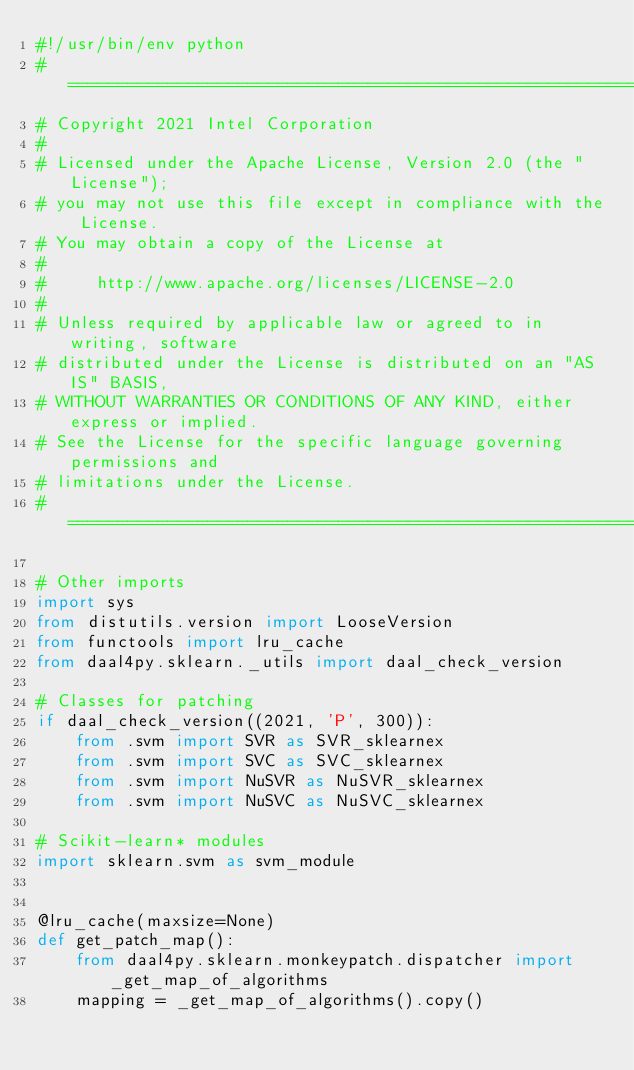<code> <loc_0><loc_0><loc_500><loc_500><_Python_>#!/usr/bin/env python
#===============================================================================
# Copyright 2021 Intel Corporation
#
# Licensed under the Apache License, Version 2.0 (the "License");
# you may not use this file except in compliance with the License.
# You may obtain a copy of the License at
#
#     http://www.apache.org/licenses/LICENSE-2.0
#
# Unless required by applicable law or agreed to in writing, software
# distributed under the License is distributed on an "AS IS" BASIS,
# WITHOUT WARRANTIES OR CONDITIONS OF ANY KIND, either express or implied.
# See the License for the specific language governing permissions and
# limitations under the License.
#===============================================================================

# Other imports
import sys
from distutils.version import LooseVersion
from functools import lru_cache
from daal4py.sklearn._utils import daal_check_version

# Classes for patching
if daal_check_version((2021, 'P', 300)):
    from .svm import SVR as SVR_sklearnex
    from .svm import SVC as SVC_sklearnex
    from .svm import NuSVR as NuSVR_sklearnex
    from .svm import NuSVC as NuSVC_sklearnex

# Scikit-learn* modules
import sklearn.svm as svm_module


@lru_cache(maxsize=None)
def get_patch_map():
    from daal4py.sklearn.monkeypatch.dispatcher import _get_map_of_algorithms
    mapping = _get_map_of_algorithms().copy()
</code> 